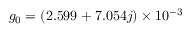<formula> <loc_0><loc_0><loc_500><loc_500>g _ { 0 } = ( 2 . 5 9 9 + 7 . 0 5 4 j ) \times 1 0 ^ { - 3 }</formula> 